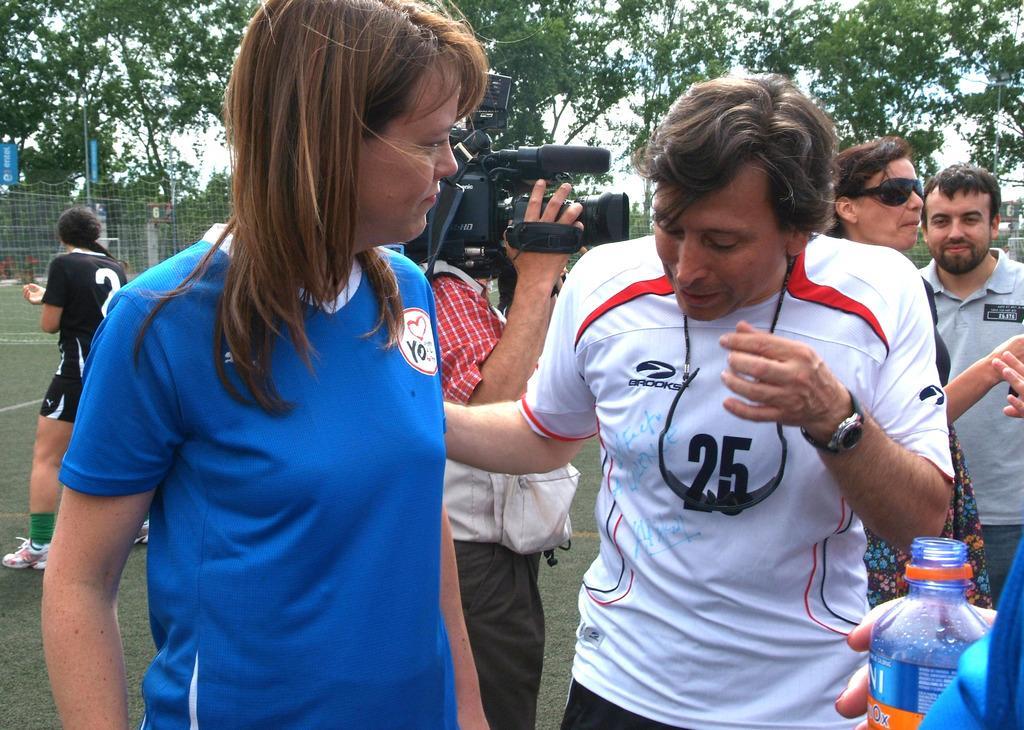Could you give a brief overview of what you see in this image? In this image there is a man and woman standing together also behind them there is other man standing and holding camera, we can see there is fence and trees at there back. 